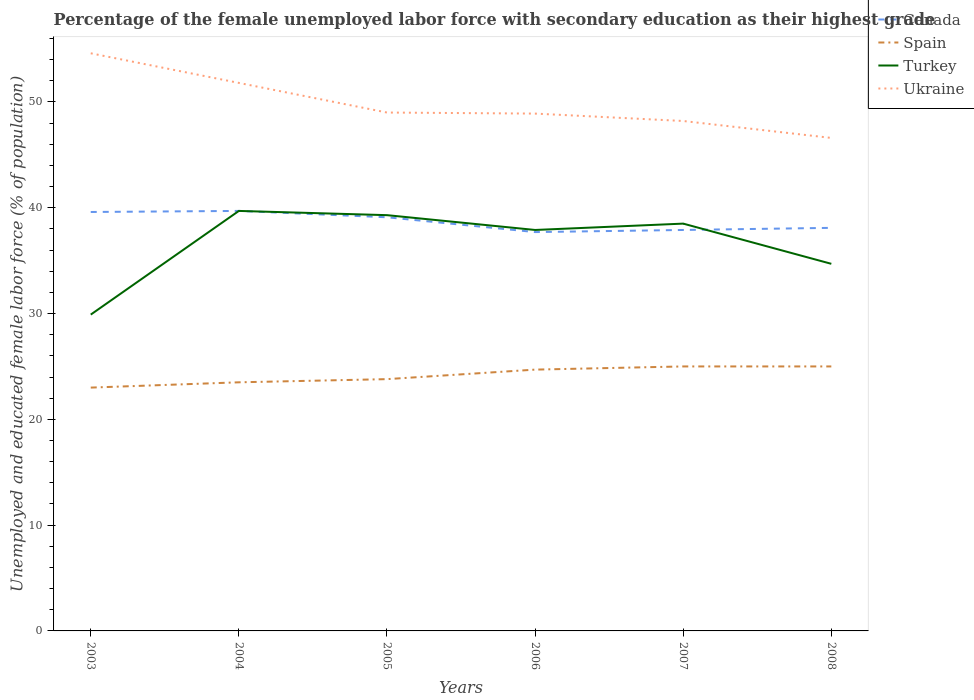How many different coloured lines are there?
Ensure brevity in your answer.  4. Across all years, what is the maximum percentage of the unemployed female labor force with secondary education in Spain?
Offer a very short reply. 23. In which year was the percentage of the unemployed female labor force with secondary education in Spain maximum?
Provide a short and direct response. 2003. What is the total percentage of the unemployed female labor force with secondary education in Ukraine in the graph?
Make the answer very short. 6.4. What is the difference between the highest and the second highest percentage of the unemployed female labor force with secondary education in Spain?
Your answer should be very brief. 2. What is the difference between the highest and the lowest percentage of the unemployed female labor force with secondary education in Turkey?
Make the answer very short. 4. How many years are there in the graph?
Ensure brevity in your answer.  6. What is the difference between two consecutive major ticks on the Y-axis?
Offer a very short reply. 10. How many legend labels are there?
Your answer should be compact. 4. What is the title of the graph?
Make the answer very short. Percentage of the female unemployed labor force with secondary education as their highest grade. Does "Cameroon" appear as one of the legend labels in the graph?
Your answer should be very brief. No. What is the label or title of the X-axis?
Ensure brevity in your answer.  Years. What is the label or title of the Y-axis?
Your answer should be compact. Unemployed and educated female labor force (% of population). What is the Unemployed and educated female labor force (% of population) in Canada in 2003?
Keep it short and to the point. 39.6. What is the Unemployed and educated female labor force (% of population) in Turkey in 2003?
Ensure brevity in your answer.  29.9. What is the Unemployed and educated female labor force (% of population) in Ukraine in 2003?
Ensure brevity in your answer.  54.6. What is the Unemployed and educated female labor force (% of population) in Canada in 2004?
Your answer should be compact. 39.7. What is the Unemployed and educated female labor force (% of population) of Turkey in 2004?
Your answer should be very brief. 39.7. What is the Unemployed and educated female labor force (% of population) in Ukraine in 2004?
Keep it short and to the point. 51.8. What is the Unemployed and educated female labor force (% of population) of Canada in 2005?
Keep it short and to the point. 39.1. What is the Unemployed and educated female labor force (% of population) of Spain in 2005?
Ensure brevity in your answer.  23.8. What is the Unemployed and educated female labor force (% of population) in Turkey in 2005?
Your response must be concise. 39.3. What is the Unemployed and educated female labor force (% of population) of Ukraine in 2005?
Make the answer very short. 49. What is the Unemployed and educated female labor force (% of population) of Canada in 2006?
Keep it short and to the point. 37.7. What is the Unemployed and educated female labor force (% of population) in Spain in 2006?
Your response must be concise. 24.7. What is the Unemployed and educated female labor force (% of population) in Turkey in 2006?
Your response must be concise. 37.9. What is the Unemployed and educated female labor force (% of population) in Ukraine in 2006?
Provide a succinct answer. 48.9. What is the Unemployed and educated female labor force (% of population) of Canada in 2007?
Provide a short and direct response. 37.9. What is the Unemployed and educated female labor force (% of population) of Spain in 2007?
Your answer should be compact. 25. What is the Unemployed and educated female labor force (% of population) of Turkey in 2007?
Provide a short and direct response. 38.5. What is the Unemployed and educated female labor force (% of population) in Ukraine in 2007?
Your answer should be compact. 48.2. What is the Unemployed and educated female labor force (% of population) in Canada in 2008?
Your response must be concise. 38.1. What is the Unemployed and educated female labor force (% of population) in Turkey in 2008?
Keep it short and to the point. 34.7. What is the Unemployed and educated female labor force (% of population) in Ukraine in 2008?
Your answer should be compact. 46.6. Across all years, what is the maximum Unemployed and educated female labor force (% of population) in Canada?
Give a very brief answer. 39.7. Across all years, what is the maximum Unemployed and educated female labor force (% of population) in Spain?
Your answer should be compact. 25. Across all years, what is the maximum Unemployed and educated female labor force (% of population) in Turkey?
Give a very brief answer. 39.7. Across all years, what is the maximum Unemployed and educated female labor force (% of population) of Ukraine?
Your answer should be very brief. 54.6. Across all years, what is the minimum Unemployed and educated female labor force (% of population) in Canada?
Make the answer very short. 37.7. Across all years, what is the minimum Unemployed and educated female labor force (% of population) in Spain?
Provide a short and direct response. 23. Across all years, what is the minimum Unemployed and educated female labor force (% of population) in Turkey?
Provide a succinct answer. 29.9. Across all years, what is the minimum Unemployed and educated female labor force (% of population) of Ukraine?
Make the answer very short. 46.6. What is the total Unemployed and educated female labor force (% of population) of Canada in the graph?
Ensure brevity in your answer.  232.1. What is the total Unemployed and educated female labor force (% of population) of Spain in the graph?
Make the answer very short. 145. What is the total Unemployed and educated female labor force (% of population) in Turkey in the graph?
Provide a succinct answer. 220. What is the total Unemployed and educated female labor force (% of population) in Ukraine in the graph?
Provide a short and direct response. 299.1. What is the difference between the Unemployed and educated female labor force (% of population) in Canada in 2003 and that in 2004?
Provide a succinct answer. -0.1. What is the difference between the Unemployed and educated female labor force (% of population) in Turkey in 2003 and that in 2004?
Provide a short and direct response. -9.8. What is the difference between the Unemployed and educated female labor force (% of population) of Ukraine in 2003 and that in 2005?
Make the answer very short. 5.6. What is the difference between the Unemployed and educated female labor force (% of population) in Spain in 2003 and that in 2006?
Provide a short and direct response. -1.7. What is the difference between the Unemployed and educated female labor force (% of population) of Canada in 2003 and that in 2007?
Your answer should be compact. 1.7. What is the difference between the Unemployed and educated female labor force (% of population) of Spain in 2003 and that in 2007?
Provide a succinct answer. -2. What is the difference between the Unemployed and educated female labor force (% of population) of Ukraine in 2003 and that in 2007?
Give a very brief answer. 6.4. What is the difference between the Unemployed and educated female labor force (% of population) in Spain in 2003 and that in 2008?
Make the answer very short. -2. What is the difference between the Unemployed and educated female labor force (% of population) in Turkey in 2003 and that in 2008?
Provide a succinct answer. -4.8. What is the difference between the Unemployed and educated female labor force (% of population) of Ukraine in 2003 and that in 2008?
Give a very brief answer. 8. What is the difference between the Unemployed and educated female labor force (% of population) of Turkey in 2004 and that in 2005?
Your response must be concise. 0.4. What is the difference between the Unemployed and educated female labor force (% of population) of Ukraine in 2004 and that in 2005?
Offer a terse response. 2.8. What is the difference between the Unemployed and educated female labor force (% of population) in Spain in 2004 and that in 2006?
Provide a short and direct response. -1.2. What is the difference between the Unemployed and educated female labor force (% of population) of Turkey in 2004 and that in 2006?
Offer a terse response. 1.8. What is the difference between the Unemployed and educated female labor force (% of population) of Spain in 2004 and that in 2007?
Make the answer very short. -1.5. What is the difference between the Unemployed and educated female labor force (% of population) in Ukraine in 2004 and that in 2007?
Provide a succinct answer. 3.6. What is the difference between the Unemployed and educated female labor force (% of population) in Spain in 2004 and that in 2008?
Your answer should be very brief. -1.5. What is the difference between the Unemployed and educated female labor force (% of population) in Ukraine in 2004 and that in 2008?
Your response must be concise. 5.2. What is the difference between the Unemployed and educated female labor force (% of population) of Turkey in 2005 and that in 2006?
Make the answer very short. 1.4. What is the difference between the Unemployed and educated female labor force (% of population) in Ukraine in 2005 and that in 2006?
Your answer should be very brief. 0.1. What is the difference between the Unemployed and educated female labor force (% of population) in Spain in 2005 and that in 2007?
Give a very brief answer. -1.2. What is the difference between the Unemployed and educated female labor force (% of population) of Turkey in 2005 and that in 2007?
Provide a succinct answer. 0.8. What is the difference between the Unemployed and educated female labor force (% of population) in Ukraine in 2005 and that in 2007?
Provide a succinct answer. 0.8. What is the difference between the Unemployed and educated female labor force (% of population) in Canada in 2005 and that in 2008?
Give a very brief answer. 1. What is the difference between the Unemployed and educated female labor force (% of population) of Spain in 2005 and that in 2008?
Keep it short and to the point. -1.2. What is the difference between the Unemployed and educated female labor force (% of population) in Turkey in 2005 and that in 2008?
Provide a short and direct response. 4.6. What is the difference between the Unemployed and educated female labor force (% of population) in Ukraine in 2006 and that in 2007?
Make the answer very short. 0.7. What is the difference between the Unemployed and educated female labor force (% of population) in Canada in 2006 and that in 2008?
Keep it short and to the point. -0.4. What is the difference between the Unemployed and educated female labor force (% of population) in Canada in 2007 and that in 2008?
Give a very brief answer. -0.2. What is the difference between the Unemployed and educated female labor force (% of population) of Turkey in 2007 and that in 2008?
Your response must be concise. 3.8. What is the difference between the Unemployed and educated female labor force (% of population) of Canada in 2003 and the Unemployed and educated female labor force (% of population) of Ukraine in 2004?
Offer a terse response. -12.2. What is the difference between the Unemployed and educated female labor force (% of population) in Spain in 2003 and the Unemployed and educated female labor force (% of population) in Turkey in 2004?
Your response must be concise. -16.7. What is the difference between the Unemployed and educated female labor force (% of population) of Spain in 2003 and the Unemployed and educated female labor force (% of population) of Ukraine in 2004?
Provide a succinct answer. -28.8. What is the difference between the Unemployed and educated female labor force (% of population) in Turkey in 2003 and the Unemployed and educated female labor force (% of population) in Ukraine in 2004?
Your answer should be compact. -21.9. What is the difference between the Unemployed and educated female labor force (% of population) of Canada in 2003 and the Unemployed and educated female labor force (% of population) of Spain in 2005?
Your answer should be very brief. 15.8. What is the difference between the Unemployed and educated female labor force (% of population) in Canada in 2003 and the Unemployed and educated female labor force (% of population) in Ukraine in 2005?
Ensure brevity in your answer.  -9.4. What is the difference between the Unemployed and educated female labor force (% of population) of Spain in 2003 and the Unemployed and educated female labor force (% of population) of Turkey in 2005?
Make the answer very short. -16.3. What is the difference between the Unemployed and educated female labor force (% of population) of Turkey in 2003 and the Unemployed and educated female labor force (% of population) of Ukraine in 2005?
Give a very brief answer. -19.1. What is the difference between the Unemployed and educated female labor force (% of population) of Canada in 2003 and the Unemployed and educated female labor force (% of population) of Spain in 2006?
Make the answer very short. 14.9. What is the difference between the Unemployed and educated female labor force (% of population) in Canada in 2003 and the Unemployed and educated female labor force (% of population) in Turkey in 2006?
Give a very brief answer. 1.7. What is the difference between the Unemployed and educated female labor force (% of population) of Spain in 2003 and the Unemployed and educated female labor force (% of population) of Turkey in 2006?
Offer a terse response. -14.9. What is the difference between the Unemployed and educated female labor force (% of population) of Spain in 2003 and the Unemployed and educated female labor force (% of population) of Ukraine in 2006?
Keep it short and to the point. -25.9. What is the difference between the Unemployed and educated female labor force (% of population) of Turkey in 2003 and the Unemployed and educated female labor force (% of population) of Ukraine in 2006?
Your response must be concise. -19. What is the difference between the Unemployed and educated female labor force (% of population) of Canada in 2003 and the Unemployed and educated female labor force (% of population) of Spain in 2007?
Your response must be concise. 14.6. What is the difference between the Unemployed and educated female labor force (% of population) of Spain in 2003 and the Unemployed and educated female labor force (% of population) of Turkey in 2007?
Provide a short and direct response. -15.5. What is the difference between the Unemployed and educated female labor force (% of population) of Spain in 2003 and the Unemployed and educated female labor force (% of population) of Ukraine in 2007?
Keep it short and to the point. -25.2. What is the difference between the Unemployed and educated female labor force (% of population) in Turkey in 2003 and the Unemployed and educated female labor force (% of population) in Ukraine in 2007?
Keep it short and to the point. -18.3. What is the difference between the Unemployed and educated female labor force (% of population) of Canada in 2003 and the Unemployed and educated female labor force (% of population) of Spain in 2008?
Make the answer very short. 14.6. What is the difference between the Unemployed and educated female labor force (% of population) of Canada in 2003 and the Unemployed and educated female labor force (% of population) of Ukraine in 2008?
Your response must be concise. -7. What is the difference between the Unemployed and educated female labor force (% of population) in Spain in 2003 and the Unemployed and educated female labor force (% of population) in Ukraine in 2008?
Provide a short and direct response. -23.6. What is the difference between the Unemployed and educated female labor force (% of population) of Turkey in 2003 and the Unemployed and educated female labor force (% of population) of Ukraine in 2008?
Provide a short and direct response. -16.7. What is the difference between the Unemployed and educated female labor force (% of population) in Canada in 2004 and the Unemployed and educated female labor force (% of population) in Ukraine in 2005?
Your response must be concise. -9.3. What is the difference between the Unemployed and educated female labor force (% of population) of Spain in 2004 and the Unemployed and educated female labor force (% of population) of Turkey in 2005?
Your answer should be very brief. -15.8. What is the difference between the Unemployed and educated female labor force (% of population) in Spain in 2004 and the Unemployed and educated female labor force (% of population) in Ukraine in 2005?
Your answer should be compact. -25.5. What is the difference between the Unemployed and educated female labor force (% of population) in Canada in 2004 and the Unemployed and educated female labor force (% of population) in Turkey in 2006?
Provide a short and direct response. 1.8. What is the difference between the Unemployed and educated female labor force (% of population) in Canada in 2004 and the Unemployed and educated female labor force (% of population) in Ukraine in 2006?
Make the answer very short. -9.2. What is the difference between the Unemployed and educated female labor force (% of population) of Spain in 2004 and the Unemployed and educated female labor force (% of population) of Turkey in 2006?
Your answer should be compact. -14.4. What is the difference between the Unemployed and educated female labor force (% of population) of Spain in 2004 and the Unemployed and educated female labor force (% of population) of Ukraine in 2006?
Offer a terse response. -25.4. What is the difference between the Unemployed and educated female labor force (% of population) in Canada in 2004 and the Unemployed and educated female labor force (% of population) in Spain in 2007?
Offer a terse response. 14.7. What is the difference between the Unemployed and educated female labor force (% of population) of Canada in 2004 and the Unemployed and educated female labor force (% of population) of Turkey in 2007?
Ensure brevity in your answer.  1.2. What is the difference between the Unemployed and educated female labor force (% of population) of Spain in 2004 and the Unemployed and educated female labor force (% of population) of Turkey in 2007?
Keep it short and to the point. -15. What is the difference between the Unemployed and educated female labor force (% of population) of Spain in 2004 and the Unemployed and educated female labor force (% of population) of Ukraine in 2007?
Your answer should be compact. -24.7. What is the difference between the Unemployed and educated female labor force (% of population) in Canada in 2004 and the Unemployed and educated female labor force (% of population) in Spain in 2008?
Your answer should be very brief. 14.7. What is the difference between the Unemployed and educated female labor force (% of population) of Canada in 2004 and the Unemployed and educated female labor force (% of population) of Turkey in 2008?
Provide a short and direct response. 5. What is the difference between the Unemployed and educated female labor force (% of population) of Spain in 2004 and the Unemployed and educated female labor force (% of population) of Turkey in 2008?
Make the answer very short. -11.2. What is the difference between the Unemployed and educated female labor force (% of population) of Spain in 2004 and the Unemployed and educated female labor force (% of population) of Ukraine in 2008?
Your answer should be compact. -23.1. What is the difference between the Unemployed and educated female labor force (% of population) in Turkey in 2004 and the Unemployed and educated female labor force (% of population) in Ukraine in 2008?
Give a very brief answer. -6.9. What is the difference between the Unemployed and educated female labor force (% of population) in Canada in 2005 and the Unemployed and educated female labor force (% of population) in Spain in 2006?
Provide a short and direct response. 14.4. What is the difference between the Unemployed and educated female labor force (% of population) of Spain in 2005 and the Unemployed and educated female labor force (% of population) of Turkey in 2006?
Your answer should be very brief. -14.1. What is the difference between the Unemployed and educated female labor force (% of population) of Spain in 2005 and the Unemployed and educated female labor force (% of population) of Ukraine in 2006?
Offer a terse response. -25.1. What is the difference between the Unemployed and educated female labor force (% of population) of Turkey in 2005 and the Unemployed and educated female labor force (% of population) of Ukraine in 2006?
Keep it short and to the point. -9.6. What is the difference between the Unemployed and educated female labor force (% of population) of Canada in 2005 and the Unemployed and educated female labor force (% of population) of Spain in 2007?
Your response must be concise. 14.1. What is the difference between the Unemployed and educated female labor force (% of population) of Canada in 2005 and the Unemployed and educated female labor force (% of population) of Turkey in 2007?
Your answer should be compact. 0.6. What is the difference between the Unemployed and educated female labor force (% of population) of Spain in 2005 and the Unemployed and educated female labor force (% of population) of Turkey in 2007?
Give a very brief answer. -14.7. What is the difference between the Unemployed and educated female labor force (% of population) in Spain in 2005 and the Unemployed and educated female labor force (% of population) in Ukraine in 2007?
Provide a short and direct response. -24.4. What is the difference between the Unemployed and educated female labor force (% of population) of Turkey in 2005 and the Unemployed and educated female labor force (% of population) of Ukraine in 2007?
Provide a short and direct response. -8.9. What is the difference between the Unemployed and educated female labor force (% of population) of Canada in 2005 and the Unemployed and educated female labor force (% of population) of Spain in 2008?
Your answer should be compact. 14.1. What is the difference between the Unemployed and educated female labor force (% of population) in Spain in 2005 and the Unemployed and educated female labor force (% of population) in Ukraine in 2008?
Your answer should be compact. -22.8. What is the difference between the Unemployed and educated female labor force (% of population) of Turkey in 2005 and the Unemployed and educated female labor force (% of population) of Ukraine in 2008?
Offer a very short reply. -7.3. What is the difference between the Unemployed and educated female labor force (% of population) of Canada in 2006 and the Unemployed and educated female labor force (% of population) of Turkey in 2007?
Keep it short and to the point. -0.8. What is the difference between the Unemployed and educated female labor force (% of population) of Spain in 2006 and the Unemployed and educated female labor force (% of population) of Ukraine in 2007?
Keep it short and to the point. -23.5. What is the difference between the Unemployed and educated female labor force (% of population) in Canada in 2006 and the Unemployed and educated female labor force (% of population) in Ukraine in 2008?
Provide a short and direct response. -8.9. What is the difference between the Unemployed and educated female labor force (% of population) of Spain in 2006 and the Unemployed and educated female labor force (% of population) of Turkey in 2008?
Your answer should be compact. -10. What is the difference between the Unemployed and educated female labor force (% of population) in Spain in 2006 and the Unemployed and educated female labor force (% of population) in Ukraine in 2008?
Offer a terse response. -21.9. What is the difference between the Unemployed and educated female labor force (% of population) of Turkey in 2006 and the Unemployed and educated female labor force (% of population) of Ukraine in 2008?
Give a very brief answer. -8.7. What is the difference between the Unemployed and educated female labor force (% of population) of Canada in 2007 and the Unemployed and educated female labor force (% of population) of Spain in 2008?
Offer a terse response. 12.9. What is the difference between the Unemployed and educated female labor force (% of population) in Canada in 2007 and the Unemployed and educated female labor force (% of population) in Ukraine in 2008?
Ensure brevity in your answer.  -8.7. What is the difference between the Unemployed and educated female labor force (% of population) in Spain in 2007 and the Unemployed and educated female labor force (% of population) in Ukraine in 2008?
Your response must be concise. -21.6. What is the average Unemployed and educated female labor force (% of population) of Canada per year?
Offer a very short reply. 38.68. What is the average Unemployed and educated female labor force (% of population) in Spain per year?
Your response must be concise. 24.17. What is the average Unemployed and educated female labor force (% of population) of Turkey per year?
Your answer should be compact. 36.67. What is the average Unemployed and educated female labor force (% of population) of Ukraine per year?
Keep it short and to the point. 49.85. In the year 2003, what is the difference between the Unemployed and educated female labor force (% of population) in Canada and Unemployed and educated female labor force (% of population) in Turkey?
Ensure brevity in your answer.  9.7. In the year 2003, what is the difference between the Unemployed and educated female labor force (% of population) of Spain and Unemployed and educated female labor force (% of population) of Turkey?
Your answer should be very brief. -6.9. In the year 2003, what is the difference between the Unemployed and educated female labor force (% of population) in Spain and Unemployed and educated female labor force (% of population) in Ukraine?
Offer a terse response. -31.6. In the year 2003, what is the difference between the Unemployed and educated female labor force (% of population) in Turkey and Unemployed and educated female labor force (% of population) in Ukraine?
Offer a terse response. -24.7. In the year 2004, what is the difference between the Unemployed and educated female labor force (% of population) in Canada and Unemployed and educated female labor force (% of population) in Spain?
Provide a succinct answer. 16.2. In the year 2004, what is the difference between the Unemployed and educated female labor force (% of population) in Canada and Unemployed and educated female labor force (% of population) in Turkey?
Your answer should be very brief. 0. In the year 2004, what is the difference between the Unemployed and educated female labor force (% of population) of Spain and Unemployed and educated female labor force (% of population) of Turkey?
Make the answer very short. -16.2. In the year 2004, what is the difference between the Unemployed and educated female labor force (% of population) of Spain and Unemployed and educated female labor force (% of population) of Ukraine?
Your answer should be very brief. -28.3. In the year 2004, what is the difference between the Unemployed and educated female labor force (% of population) of Turkey and Unemployed and educated female labor force (% of population) of Ukraine?
Provide a short and direct response. -12.1. In the year 2005, what is the difference between the Unemployed and educated female labor force (% of population) in Spain and Unemployed and educated female labor force (% of population) in Turkey?
Offer a terse response. -15.5. In the year 2005, what is the difference between the Unemployed and educated female labor force (% of population) of Spain and Unemployed and educated female labor force (% of population) of Ukraine?
Your answer should be compact. -25.2. In the year 2006, what is the difference between the Unemployed and educated female labor force (% of population) of Canada and Unemployed and educated female labor force (% of population) of Turkey?
Keep it short and to the point. -0.2. In the year 2006, what is the difference between the Unemployed and educated female labor force (% of population) in Canada and Unemployed and educated female labor force (% of population) in Ukraine?
Offer a terse response. -11.2. In the year 2006, what is the difference between the Unemployed and educated female labor force (% of population) of Spain and Unemployed and educated female labor force (% of population) of Turkey?
Make the answer very short. -13.2. In the year 2006, what is the difference between the Unemployed and educated female labor force (% of population) in Spain and Unemployed and educated female labor force (% of population) in Ukraine?
Provide a short and direct response. -24.2. In the year 2006, what is the difference between the Unemployed and educated female labor force (% of population) of Turkey and Unemployed and educated female labor force (% of population) of Ukraine?
Offer a very short reply. -11. In the year 2007, what is the difference between the Unemployed and educated female labor force (% of population) in Canada and Unemployed and educated female labor force (% of population) in Spain?
Provide a short and direct response. 12.9. In the year 2007, what is the difference between the Unemployed and educated female labor force (% of population) of Spain and Unemployed and educated female labor force (% of population) of Ukraine?
Keep it short and to the point. -23.2. In the year 2007, what is the difference between the Unemployed and educated female labor force (% of population) of Turkey and Unemployed and educated female labor force (% of population) of Ukraine?
Your answer should be compact. -9.7. In the year 2008, what is the difference between the Unemployed and educated female labor force (% of population) of Canada and Unemployed and educated female labor force (% of population) of Spain?
Offer a terse response. 13.1. In the year 2008, what is the difference between the Unemployed and educated female labor force (% of population) of Canada and Unemployed and educated female labor force (% of population) of Turkey?
Provide a short and direct response. 3.4. In the year 2008, what is the difference between the Unemployed and educated female labor force (% of population) of Spain and Unemployed and educated female labor force (% of population) of Turkey?
Give a very brief answer. -9.7. In the year 2008, what is the difference between the Unemployed and educated female labor force (% of population) of Spain and Unemployed and educated female labor force (% of population) of Ukraine?
Keep it short and to the point. -21.6. In the year 2008, what is the difference between the Unemployed and educated female labor force (% of population) in Turkey and Unemployed and educated female labor force (% of population) in Ukraine?
Provide a short and direct response. -11.9. What is the ratio of the Unemployed and educated female labor force (% of population) of Canada in 2003 to that in 2004?
Ensure brevity in your answer.  1. What is the ratio of the Unemployed and educated female labor force (% of population) of Spain in 2003 to that in 2004?
Offer a terse response. 0.98. What is the ratio of the Unemployed and educated female labor force (% of population) of Turkey in 2003 to that in 2004?
Offer a terse response. 0.75. What is the ratio of the Unemployed and educated female labor force (% of population) of Ukraine in 2003 to that in 2004?
Your response must be concise. 1.05. What is the ratio of the Unemployed and educated female labor force (% of population) in Canada in 2003 to that in 2005?
Offer a terse response. 1.01. What is the ratio of the Unemployed and educated female labor force (% of population) in Spain in 2003 to that in 2005?
Offer a very short reply. 0.97. What is the ratio of the Unemployed and educated female labor force (% of population) in Turkey in 2003 to that in 2005?
Provide a short and direct response. 0.76. What is the ratio of the Unemployed and educated female labor force (% of population) of Ukraine in 2003 to that in 2005?
Provide a short and direct response. 1.11. What is the ratio of the Unemployed and educated female labor force (% of population) of Canada in 2003 to that in 2006?
Ensure brevity in your answer.  1.05. What is the ratio of the Unemployed and educated female labor force (% of population) in Spain in 2003 to that in 2006?
Keep it short and to the point. 0.93. What is the ratio of the Unemployed and educated female labor force (% of population) in Turkey in 2003 to that in 2006?
Give a very brief answer. 0.79. What is the ratio of the Unemployed and educated female labor force (% of population) of Ukraine in 2003 to that in 2006?
Provide a succinct answer. 1.12. What is the ratio of the Unemployed and educated female labor force (% of population) in Canada in 2003 to that in 2007?
Give a very brief answer. 1.04. What is the ratio of the Unemployed and educated female labor force (% of population) in Turkey in 2003 to that in 2007?
Keep it short and to the point. 0.78. What is the ratio of the Unemployed and educated female labor force (% of population) of Ukraine in 2003 to that in 2007?
Keep it short and to the point. 1.13. What is the ratio of the Unemployed and educated female labor force (% of population) of Canada in 2003 to that in 2008?
Offer a terse response. 1.04. What is the ratio of the Unemployed and educated female labor force (% of population) in Turkey in 2003 to that in 2008?
Make the answer very short. 0.86. What is the ratio of the Unemployed and educated female labor force (% of population) in Ukraine in 2003 to that in 2008?
Provide a succinct answer. 1.17. What is the ratio of the Unemployed and educated female labor force (% of population) of Canada in 2004 to that in 2005?
Ensure brevity in your answer.  1.02. What is the ratio of the Unemployed and educated female labor force (% of population) of Spain in 2004 to that in 2005?
Offer a very short reply. 0.99. What is the ratio of the Unemployed and educated female labor force (% of population) of Turkey in 2004 to that in 2005?
Offer a terse response. 1.01. What is the ratio of the Unemployed and educated female labor force (% of population) of Ukraine in 2004 to that in 2005?
Ensure brevity in your answer.  1.06. What is the ratio of the Unemployed and educated female labor force (% of population) of Canada in 2004 to that in 2006?
Offer a terse response. 1.05. What is the ratio of the Unemployed and educated female labor force (% of population) of Spain in 2004 to that in 2006?
Make the answer very short. 0.95. What is the ratio of the Unemployed and educated female labor force (% of population) of Turkey in 2004 to that in 2006?
Ensure brevity in your answer.  1.05. What is the ratio of the Unemployed and educated female labor force (% of population) in Ukraine in 2004 to that in 2006?
Provide a short and direct response. 1.06. What is the ratio of the Unemployed and educated female labor force (% of population) of Canada in 2004 to that in 2007?
Provide a short and direct response. 1.05. What is the ratio of the Unemployed and educated female labor force (% of population) in Spain in 2004 to that in 2007?
Your answer should be compact. 0.94. What is the ratio of the Unemployed and educated female labor force (% of population) of Turkey in 2004 to that in 2007?
Keep it short and to the point. 1.03. What is the ratio of the Unemployed and educated female labor force (% of population) of Ukraine in 2004 to that in 2007?
Make the answer very short. 1.07. What is the ratio of the Unemployed and educated female labor force (% of population) in Canada in 2004 to that in 2008?
Your response must be concise. 1.04. What is the ratio of the Unemployed and educated female labor force (% of population) in Spain in 2004 to that in 2008?
Make the answer very short. 0.94. What is the ratio of the Unemployed and educated female labor force (% of population) of Turkey in 2004 to that in 2008?
Ensure brevity in your answer.  1.14. What is the ratio of the Unemployed and educated female labor force (% of population) in Ukraine in 2004 to that in 2008?
Your answer should be very brief. 1.11. What is the ratio of the Unemployed and educated female labor force (% of population) in Canada in 2005 to that in 2006?
Make the answer very short. 1.04. What is the ratio of the Unemployed and educated female labor force (% of population) in Spain in 2005 to that in 2006?
Give a very brief answer. 0.96. What is the ratio of the Unemployed and educated female labor force (% of population) in Turkey in 2005 to that in 2006?
Ensure brevity in your answer.  1.04. What is the ratio of the Unemployed and educated female labor force (% of population) in Ukraine in 2005 to that in 2006?
Keep it short and to the point. 1. What is the ratio of the Unemployed and educated female labor force (% of population) of Canada in 2005 to that in 2007?
Your answer should be very brief. 1.03. What is the ratio of the Unemployed and educated female labor force (% of population) of Spain in 2005 to that in 2007?
Provide a short and direct response. 0.95. What is the ratio of the Unemployed and educated female labor force (% of population) in Turkey in 2005 to that in 2007?
Provide a short and direct response. 1.02. What is the ratio of the Unemployed and educated female labor force (% of population) in Ukraine in 2005 to that in 2007?
Make the answer very short. 1.02. What is the ratio of the Unemployed and educated female labor force (% of population) in Canada in 2005 to that in 2008?
Make the answer very short. 1.03. What is the ratio of the Unemployed and educated female labor force (% of population) of Spain in 2005 to that in 2008?
Keep it short and to the point. 0.95. What is the ratio of the Unemployed and educated female labor force (% of population) of Turkey in 2005 to that in 2008?
Make the answer very short. 1.13. What is the ratio of the Unemployed and educated female labor force (% of population) in Ukraine in 2005 to that in 2008?
Offer a terse response. 1.05. What is the ratio of the Unemployed and educated female labor force (% of population) of Canada in 2006 to that in 2007?
Offer a very short reply. 0.99. What is the ratio of the Unemployed and educated female labor force (% of population) of Spain in 2006 to that in 2007?
Give a very brief answer. 0.99. What is the ratio of the Unemployed and educated female labor force (% of population) in Turkey in 2006 to that in 2007?
Keep it short and to the point. 0.98. What is the ratio of the Unemployed and educated female labor force (% of population) in Ukraine in 2006 to that in 2007?
Make the answer very short. 1.01. What is the ratio of the Unemployed and educated female labor force (% of population) of Turkey in 2006 to that in 2008?
Your response must be concise. 1.09. What is the ratio of the Unemployed and educated female labor force (% of population) in Ukraine in 2006 to that in 2008?
Offer a terse response. 1.05. What is the ratio of the Unemployed and educated female labor force (% of population) of Canada in 2007 to that in 2008?
Ensure brevity in your answer.  0.99. What is the ratio of the Unemployed and educated female labor force (% of population) in Turkey in 2007 to that in 2008?
Provide a succinct answer. 1.11. What is the ratio of the Unemployed and educated female labor force (% of population) of Ukraine in 2007 to that in 2008?
Make the answer very short. 1.03. What is the difference between the highest and the lowest Unemployed and educated female labor force (% of population) of Canada?
Your answer should be compact. 2. What is the difference between the highest and the lowest Unemployed and educated female labor force (% of population) in Spain?
Provide a short and direct response. 2. 